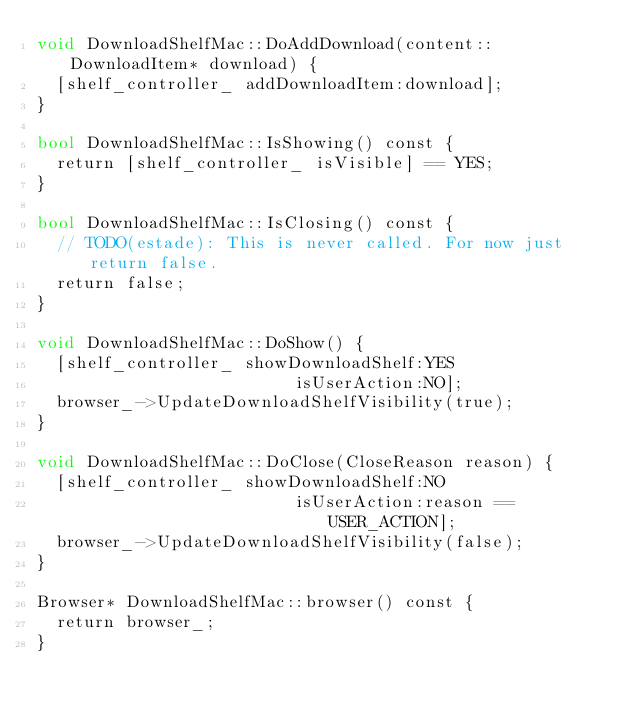Convert code to text. <code><loc_0><loc_0><loc_500><loc_500><_ObjectiveC_>void DownloadShelfMac::DoAddDownload(content::DownloadItem* download) {
  [shelf_controller_ addDownloadItem:download];
}

bool DownloadShelfMac::IsShowing() const {
  return [shelf_controller_ isVisible] == YES;
}

bool DownloadShelfMac::IsClosing() const {
  // TODO(estade): This is never called. For now just return false.
  return false;
}

void DownloadShelfMac::DoShow() {
  [shelf_controller_ showDownloadShelf:YES
                          isUserAction:NO];
  browser_->UpdateDownloadShelfVisibility(true);
}

void DownloadShelfMac::DoClose(CloseReason reason) {
  [shelf_controller_ showDownloadShelf:NO
                          isUserAction:reason == USER_ACTION];
  browser_->UpdateDownloadShelfVisibility(false);
}

Browser* DownloadShelfMac::browser() const {
  return browser_;
}
</code> 